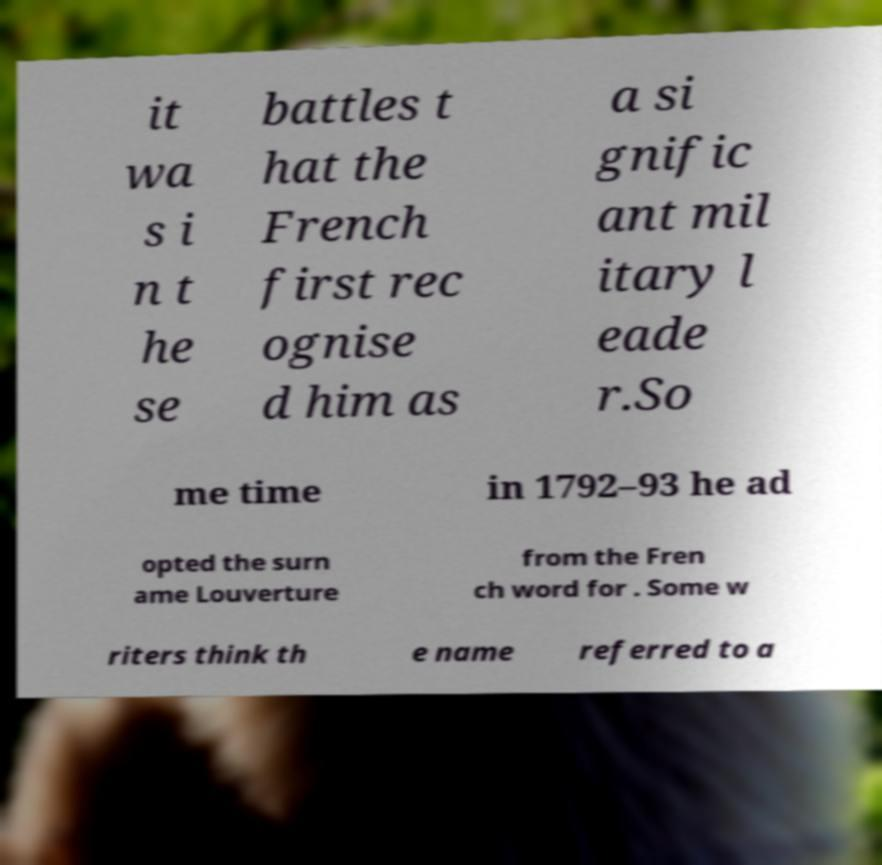Please read and relay the text visible in this image. What does it say? it wa s i n t he se battles t hat the French first rec ognise d him as a si gnific ant mil itary l eade r.So me time in 1792–93 he ad opted the surn ame Louverture from the Fren ch word for . Some w riters think th e name referred to a 